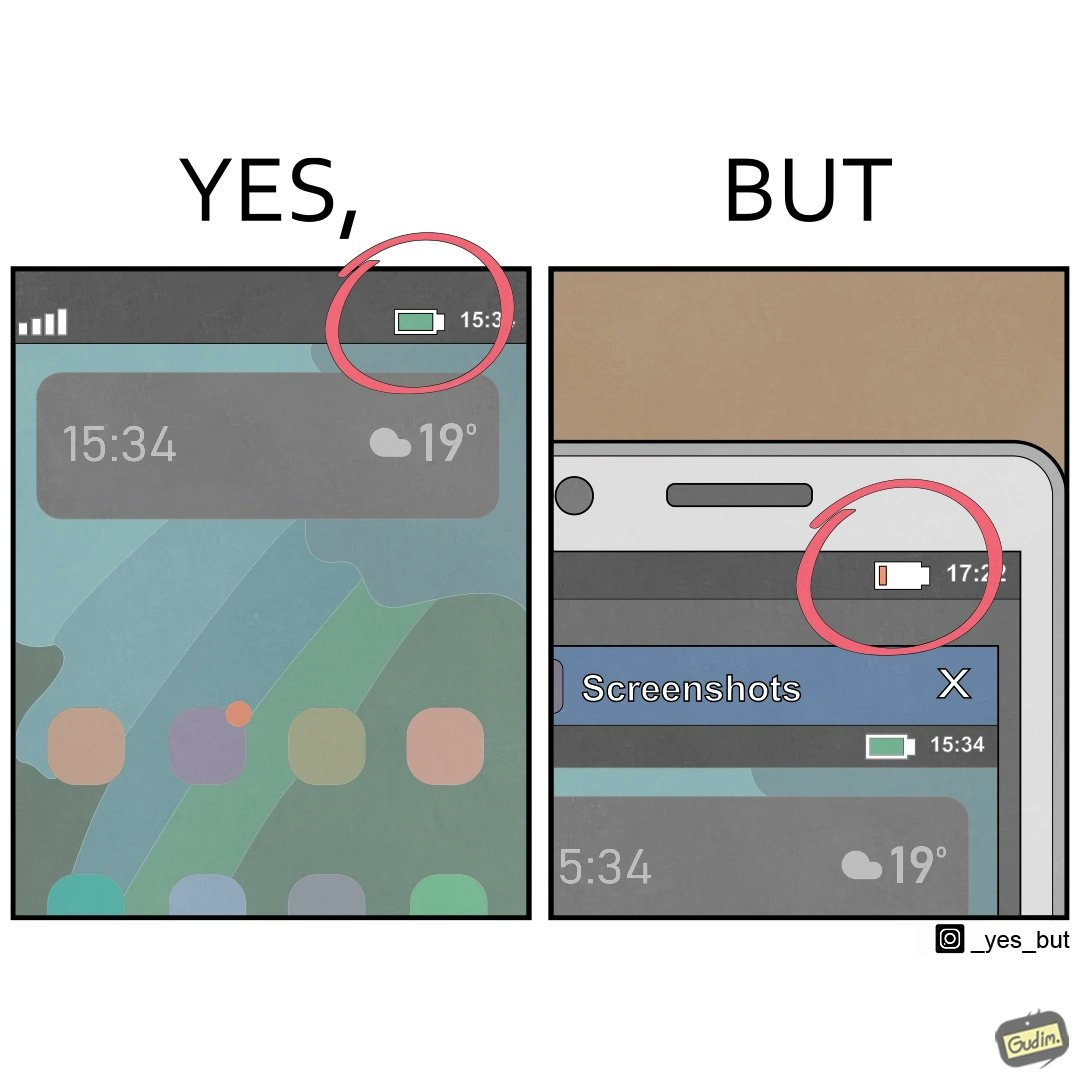What is the satirical meaning behind this image? The image is ironic, because 